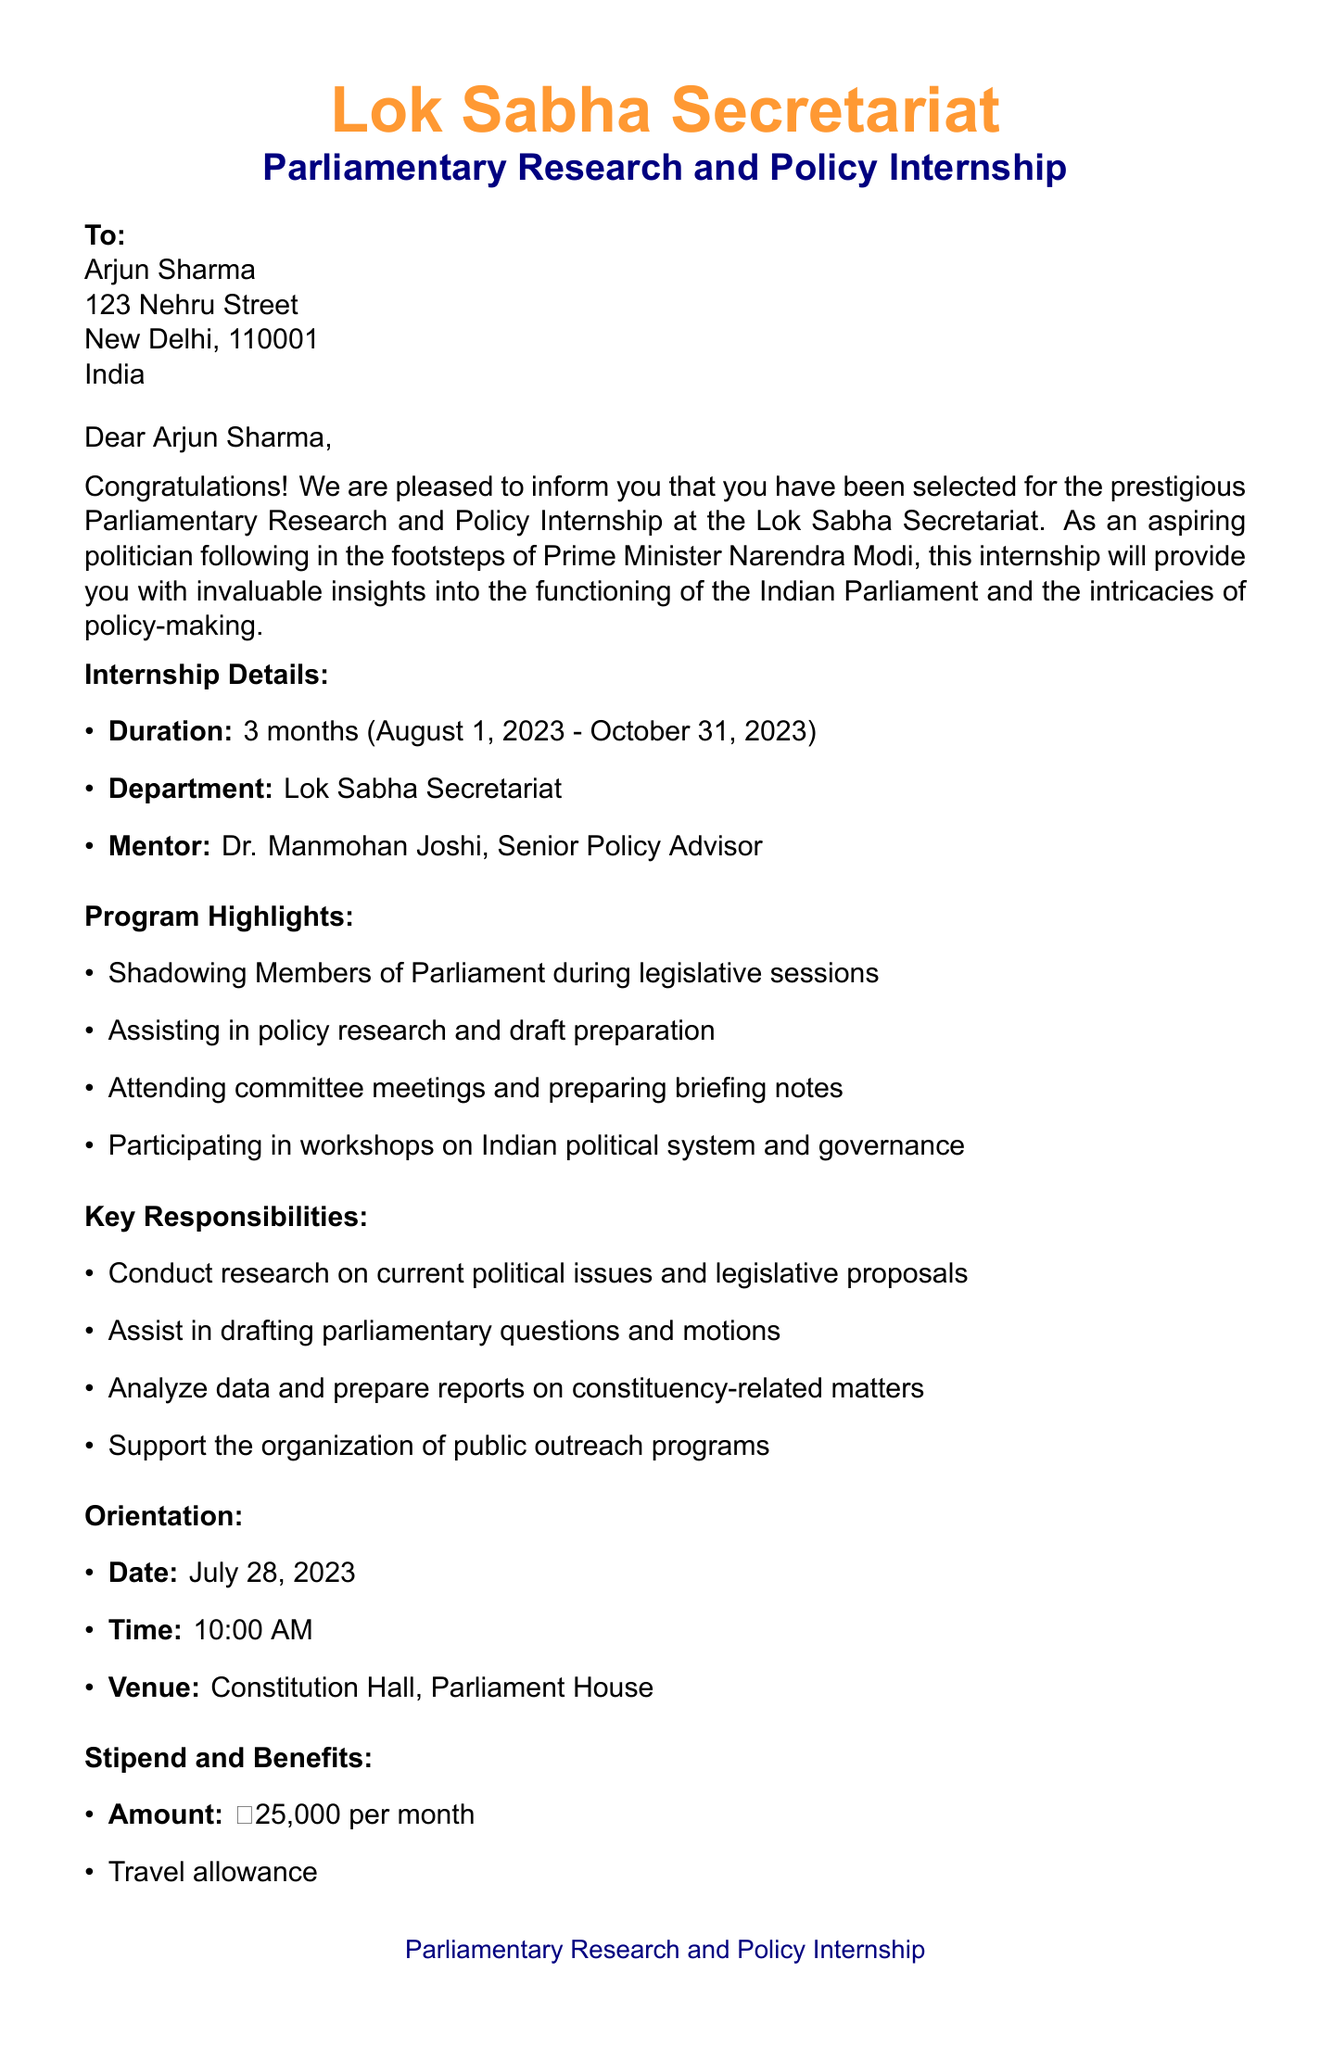What is the name of the internship program? The internship program's name is mentioned in the document as "Parliamentary Research and Policy Internship."
Answer: Parliamentary Research and Policy Internship Who is the mentor for the internship? The document specifies that the mentor for the internship is Dr. Manmohan Joshi.
Answer: Dr. Manmohan Joshi What is the duration of the internship? The duration is indicated in the letter as "3 months."
Answer: 3 months When does the internship start? The start date of the internship is explicitly mentioned as August 1, 2023.
Answer: August 1, 2023 What is the amount of the monthly stipend? The letter states that the stipend amount is ₹25,000 per month.
Answer: ₹25,000 What is one responsibility of the intern? The document lists multiple responsibilities, one of which is "Conduct research on current political issues and legislative proposals."
Answer: Conduct research on current political issues and legislative proposals What is the orientation date for the internship? The orientation date is given in the document as July 28, 2023.
Answer: July 28, 2023 Who should the required documents be submitted to? The letter specifies that the required documents should be submitted to Ms. Priya Desai.
Answer: Ms. Priya Desai 